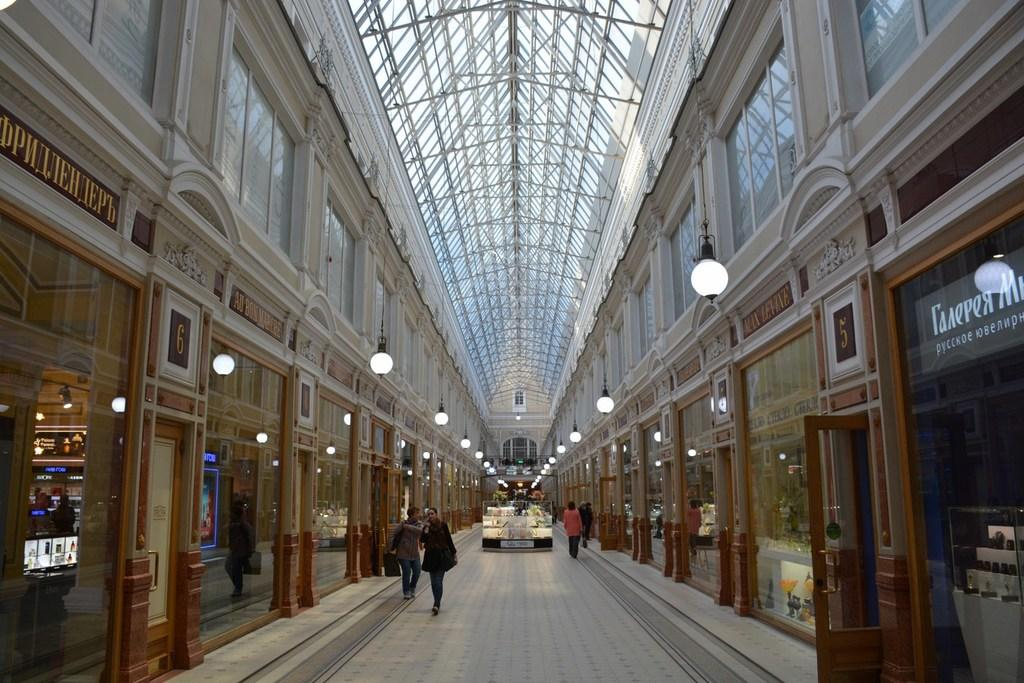What are the people in the image doing? The people in the image are on the floor. What can be seen in the background of the image? There are lights, a glass wall, and doors in the background of the image. What is visible above the people in the image? There is a ceiling visible in the image. How many grapes are being held by the people in the image? There are no grapes visible in the image; the people are on the floor without any grapes. 